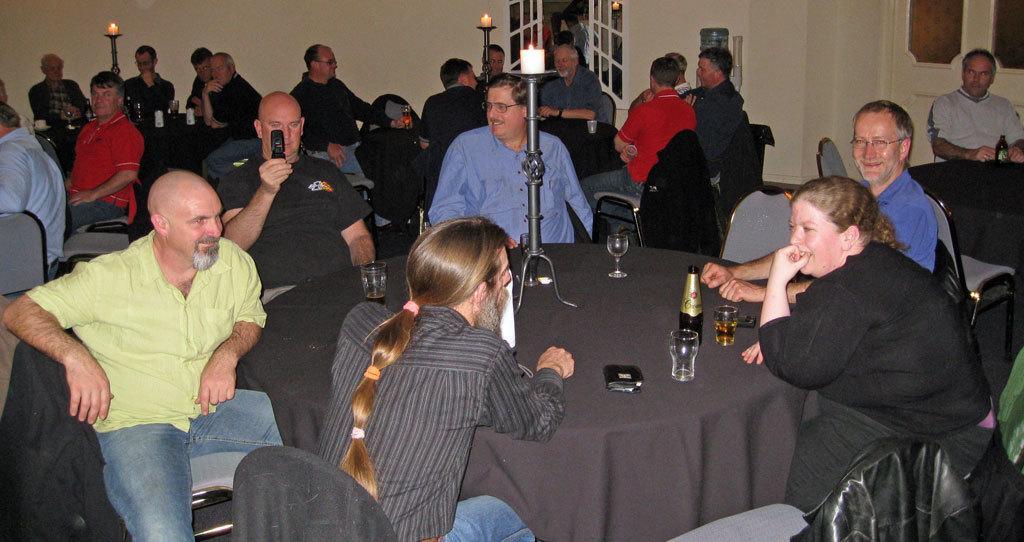Could you give a brief overview of what you see in this image? In this image we can see many people sitting on chairs. There are tables. On the tables there are bottles, glasses and candle stands with candle and flame. In the back there are doors. Also there is wall. 